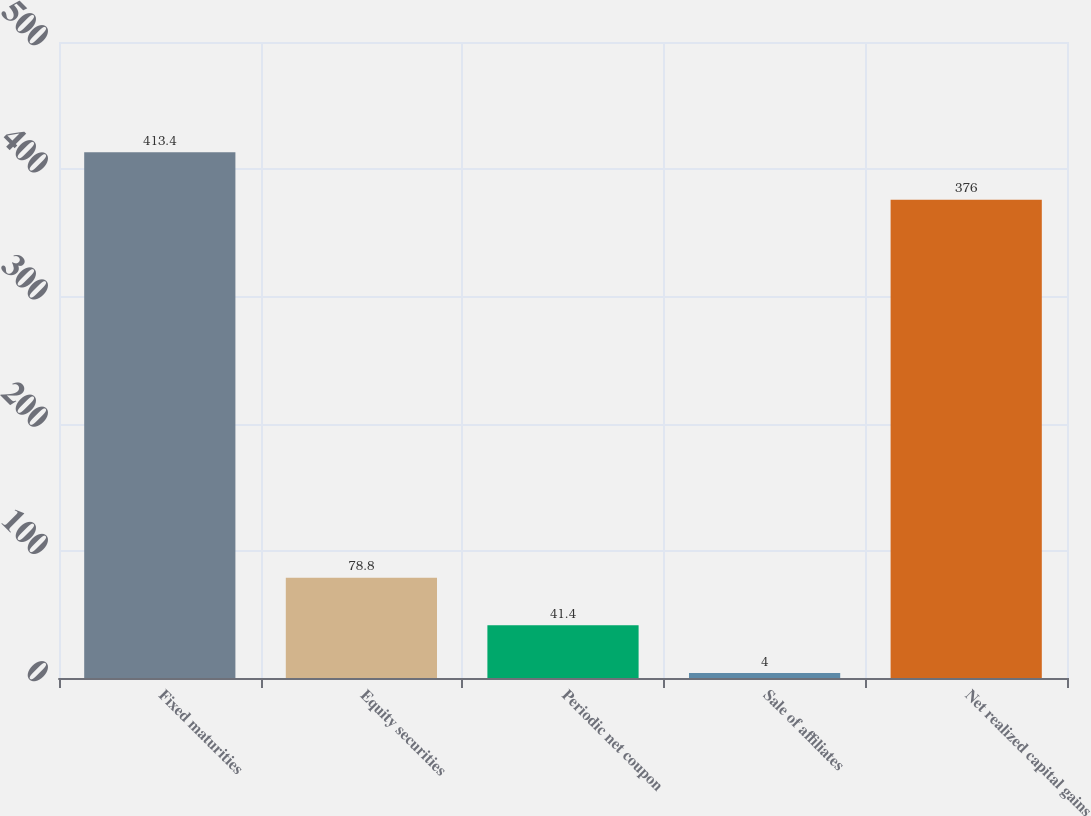Convert chart. <chart><loc_0><loc_0><loc_500><loc_500><bar_chart><fcel>Fixed maturities<fcel>Equity securities<fcel>Periodic net coupon<fcel>Sale of affiliates<fcel>Net realized capital gains<nl><fcel>413.4<fcel>78.8<fcel>41.4<fcel>4<fcel>376<nl></chart> 